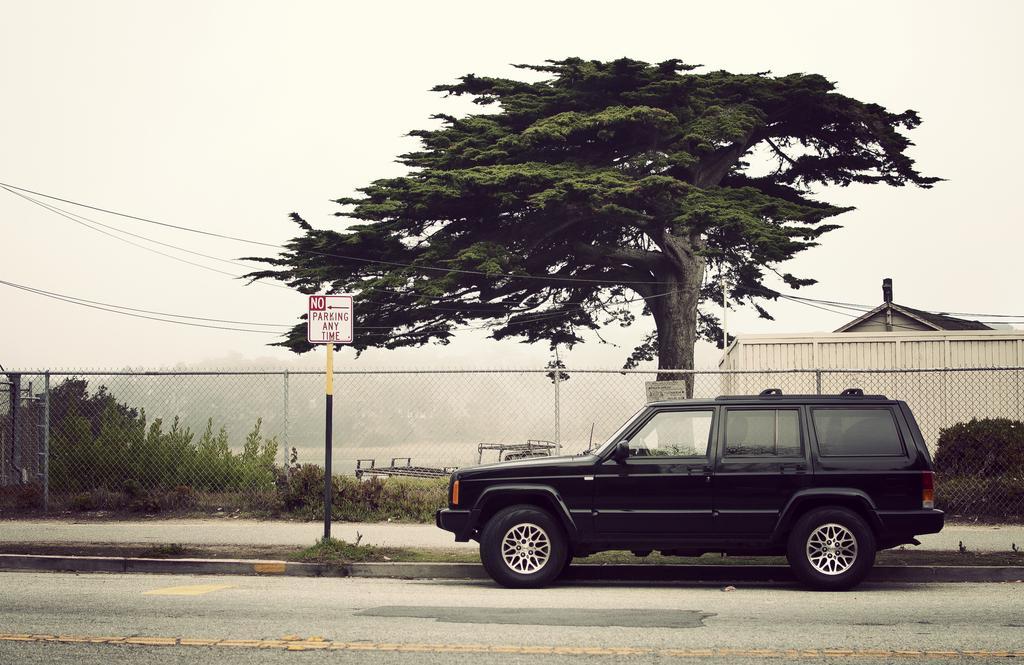How would you summarize this image in a sentence or two? This is an outside view. On the right side there is a vehicle on the road. Behind there is a net fencing. Beside the road there is a pole. In the background there are many trees. On the right side there is a building. At the top of the image I can see the sky. 